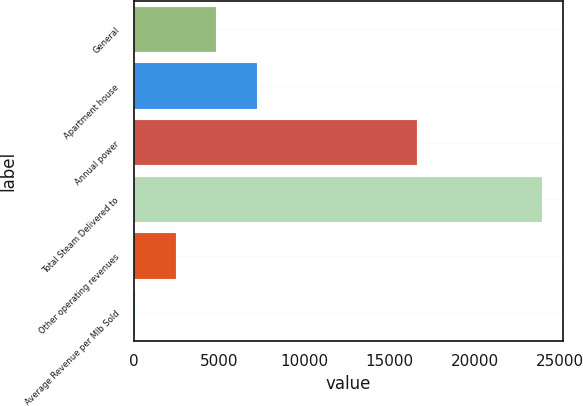Convert chart. <chart><loc_0><loc_0><loc_500><loc_500><bar_chart><fcel>General<fcel>Apartment house<fcel>Annual power<fcel>Total Steam Delivered to<fcel>Other operating revenues<fcel>Average Revenue per Mlb Sold<nl><fcel>4817.8<fcel>7212.58<fcel>16577<fcel>23976<fcel>2423.02<fcel>28.24<nl></chart> 